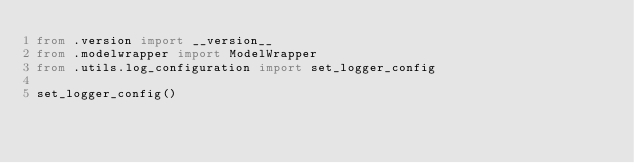Convert code to text. <code><loc_0><loc_0><loc_500><loc_500><_Python_>from .version import __version__
from .modelwrapper import ModelWrapper
from .utils.log_configuration import set_logger_config

set_logger_config()
</code> 